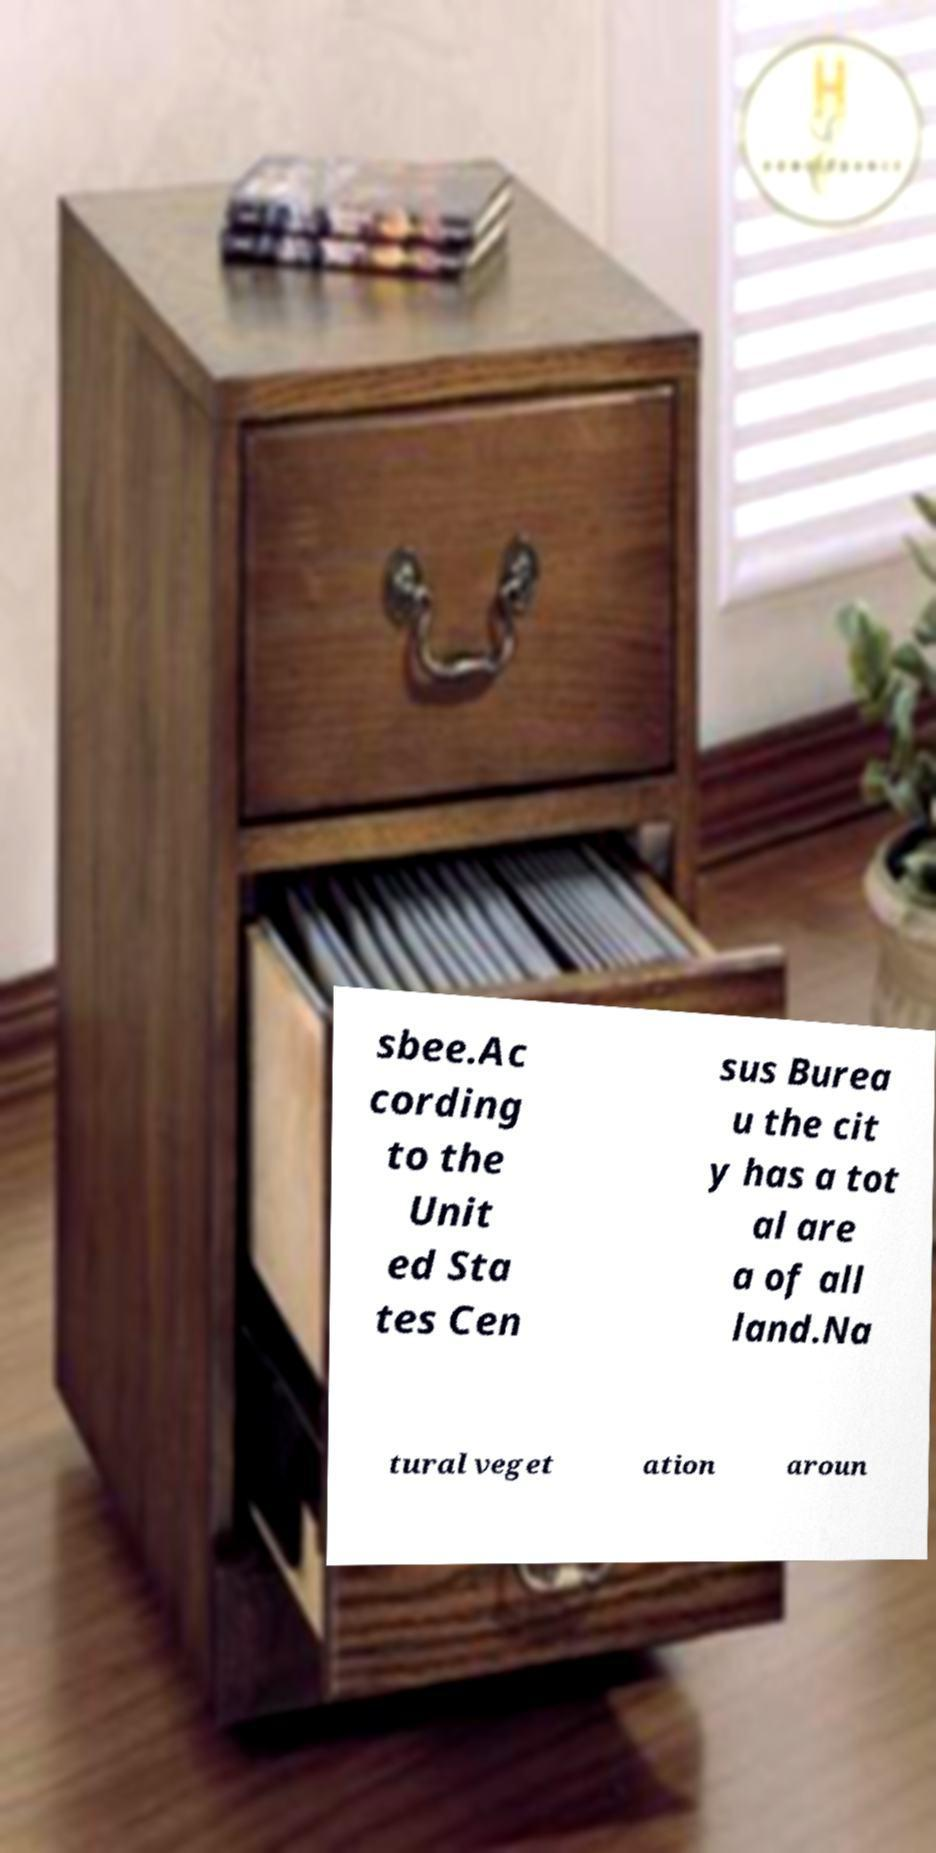There's text embedded in this image that I need extracted. Can you transcribe it verbatim? sbee.Ac cording to the Unit ed Sta tes Cen sus Burea u the cit y has a tot al are a of all land.Na tural veget ation aroun 